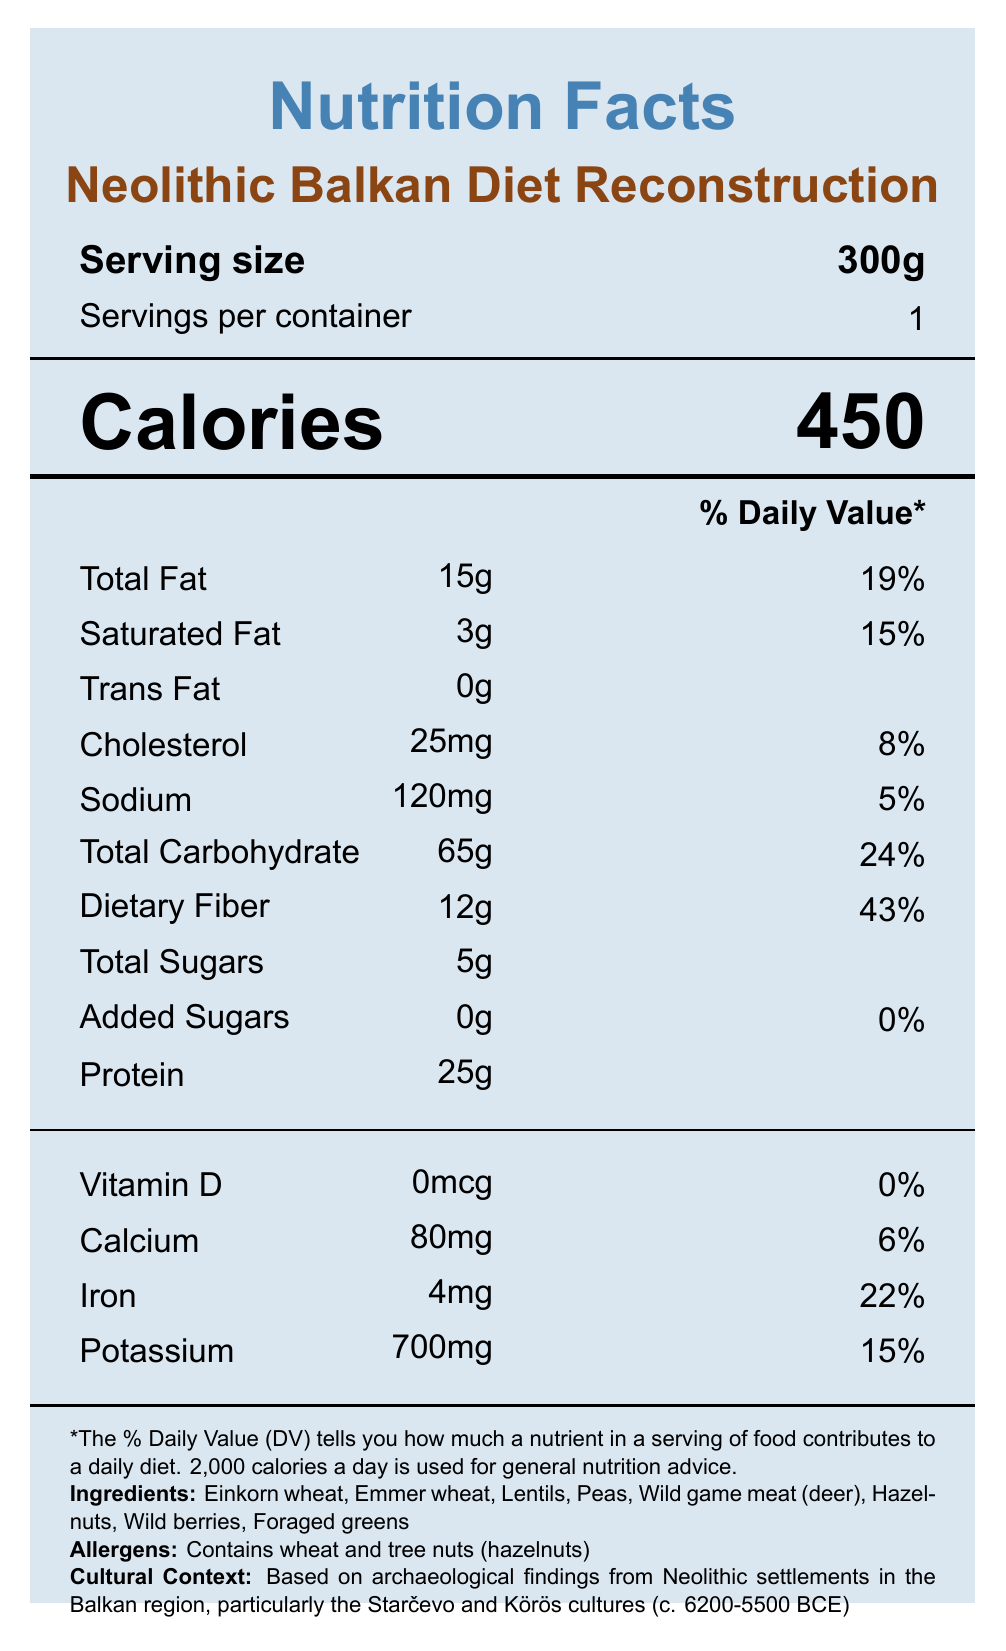what is the serving size? The serving size is explicitly stated as 300g under the "Serving size" heading.
Answer: 300g how many calories are in one serving? The number of calories per serving is prominently displayed under the "Calories" heading.
Answer: 450 how much total fat is in one serving? The total fat content is listed as 15g in the "Total Fat" section.
Answer: 15g what percentage of the daily value is the dietary fiber content? The dietary fiber percentage of the daily value is given as 43% in the "Dietary Fiber" section.
Answer: 43% what ingredients does the Neolithic Balkan diet include? The ingredients are listed in the footnote section under "Ingredients."
Answer: Einkorn wheat, Emmer wheat, Lentils, Peas, Wild game meat (deer), Hazelnuts, Wild berries, Foraged greens based on the nutritional data, which nutrient has the highest percentage of the daily value? Dietary fiber has the highest percentage of the daily value, listed as 43%.
Answer: Dietary Fiber how many milligrams of iron are in one serving? The iron content is listed as 4mg in the "Iron" section.
Answer: 4mg what archaeological sources were used for this diet reconstruction? The archaeological sources are listed under "Archaeological Sources" in the footnote section.
Answer: Charred plant remains, Faunal assemblages, Isotope analysis of human remains how does the reconstructed diet differ from later Balkan diets? 
A. Includes dairy and domesticated animal products 
B. Lacks dairy and domesticated animal products 
C. Contains rice and maize 
D. Utilizes modern agricultural practices The reconstructed diet lacks dairy and domesticated animal products, unlike later Balkan diets which include them. This is mentioned in the comparative notes.
Answer: B which vitamin or mineral has a daily value percentage of exactly 15%? 
I. Calcium 
II. Iron 
III. Potassium 
IV. Vitamin D Potassium has a daily value percentage of 15%, as noted in the "Potassium" section.
Answer: III. Potassium does the product contain any allergens? The allergen warning states that it contains wheat and tree nuts (hazelnuts).
Answer: Yes summarize the main idea of the nutrition facts label. The Nutrition Facts label outlines the reconstructed Neolithic Balkan diet by detailing its nutritional content, ingredients, and cultural background. It also includes additional context such as archaeological sources and comparative notes regarding the diet.
Answer: The document provides a detailed Nutrition Facts label for a reconstructed Neolithic Balkan diet, including nutritional information, ingredients, allergens, cultural context, archaeological sources, and dietary notes. It outlines the components and historical context of a diet based on findings from Neolithic Balkan settlements. can you determine the method used for zooarchaeological studies from the document? The document mentions zooarchaeological studies under research methods, but it does not provide details about the specific methods used.
Answer: Not enough information 